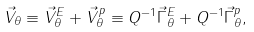<formula> <loc_0><loc_0><loc_500><loc_500>\vec { V } _ { \theta } \equiv \vec { V } _ { \theta } ^ { E } + \vec { V } _ { \theta } ^ { p } \equiv Q ^ { - 1 } \vec { \Gamma } _ { \theta } ^ { E } + Q ^ { - 1 } \vec { \Gamma } _ { \theta } ^ { p } ,</formula> 